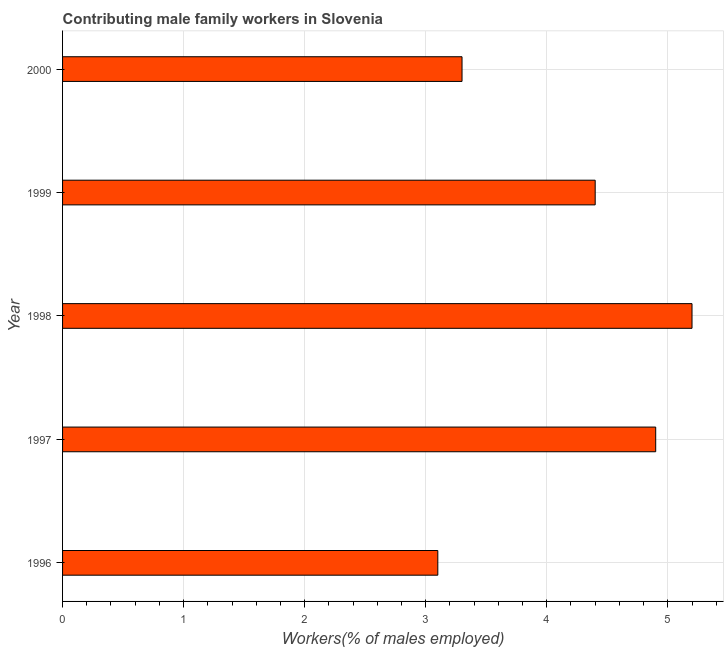Does the graph contain any zero values?
Your answer should be very brief. No. What is the title of the graph?
Your answer should be compact. Contributing male family workers in Slovenia. What is the label or title of the X-axis?
Make the answer very short. Workers(% of males employed). What is the label or title of the Y-axis?
Your answer should be compact. Year. What is the contributing male family workers in 1997?
Provide a succinct answer. 4.9. Across all years, what is the maximum contributing male family workers?
Keep it short and to the point. 5.2. Across all years, what is the minimum contributing male family workers?
Your response must be concise. 3.1. In which year was the contributing male family workers maximum?
Give a very brief answer. 1998. In which year was the contributing male family workers minimum?
Ensure brevity in your answer.  1996. What is the sum of the contributing male family workers?
Give a very brief answer. 20.9. What is the difference between the contributing male family workers in 1998 and 1999?
Offer a very short reply. 0.8. What is the average contributing male family workers per year?
Your response must be concise. 4.18. What is the median contributing male family workers?
Provide a succinct answer. 4.4. In how many years, is the contributing male family workers greater than 2.6 %?
Provide a short and direct response. 5. What is the ratio of the contributing male family workers in 1996 to that in 1997?
Ensure brevity in your answer.  0.63. What is the difference between the highest and the second highest contributing male family workers?
Provide a short and direct response. 0.3. Is the sum of the contributing male family workers in 1996 and 1999 greater than the maximum contributing male family workers across all years?
Ensure brevity in your answer.  Yes. What is the difference between the highest and the lowest contributing male family workers?
Offer a terse response. 2.1. In how many years, is the contributing male family workers greater than the average contributing male family workers taken over all years?
Provide a succinct answer. 3. How many years are there in the graph?
Offer a terse response. 5. What is the difference between two consecutive major ticks on the X-axis?
Give a very brief answer. 1. Are the values on the major ticks of X-axis written in scientific E-notation?
Your answer should be compact. No. What is the Workers(% of males employed) of 1996?
Offer a very short reply. 3.1. What is the Workers(% of males employed) of 1997?
Offer a terse response. 4.9. What is the Workers(% of males employed) of 1998?
Give a very brief answer. 5.2. What is the Workers(% of males employed) in 1999?
Offer a terse response. 4.4. What is the Workers(% of males employed) in 2000?
Your answer should be compact. 3.3. What is the difference between the Workers(% of males employed) in 1996 and 1997?
Ensure brevity in your answer.  -1.8. What is the difference between the Workers(% of males employed) in 1996 and 2000?
Make the answer very short. -0.2. What is the difference between the Workers(% of males employed) in 1997 and 1998?
Your answer should be compact. -0.3. What is the difference between the Workers(% of males employed) in 1998 and 2000?
Ensure brevity in your answer.  1.9. What is the difference between the Workers(% of males employed) in 1999 and 2000?
Keep it short and to the point. 1.1. What is the ratio of the Workers(% of males employed) in 1996 to that in 1997?
Give a very brief answer. 0.63. What is the ratio of the Workers(% of males employed) in 1996 to that in 1998?
Make the answer very short. 0.6. What is the ratio of the Workers(% of males employed) in 1996 to that in 1999?
Offer a terse response. 0.7. What is the ratio of the Workers(% of males employed) in 1996 to that in 2000?
Provide a succinct answer. 0.94. What is the ratio of the Workers(% of males employed) in 1997 to that in 1998?
Your answer should be compact. 0.94. What is the ratio of the Workers(% of males employed) in 1997 to that in 1999?
Keep it short and to the point. 1.11. What is the ratio of the Workers(% of males employed) in 1997 to that in 2000?
Give a very brief answer. 1.49. What is the ratio of the Workers(% of males employed) in 1998 to that in 1999?
Your response must be concise. 1.18. What is the ratio of the Workers(% of males employed) in 1998 to that in 2000?
Your answer should be very brief. 1.58. What is the ratio of the Workers(% of males employed) in 1999 to that in 2000?
Make the answer very short. 1.33. 